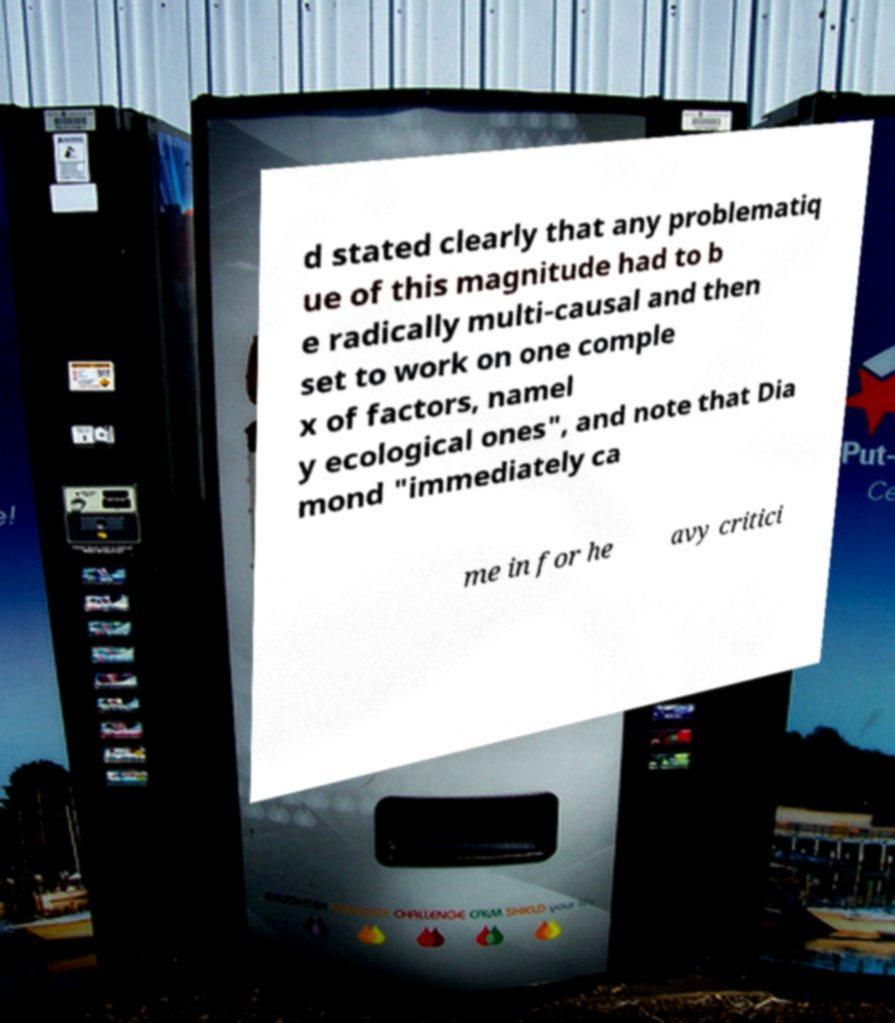Please read and relay the text visible in this image. What does it say? d stated clearly that any problematiq ue of this magnitude had to b e radically multi-causal and then set to work on one comple x of factors, namel y ecological ones", and note that Dia mond "immediately ca me in for he avy critici 